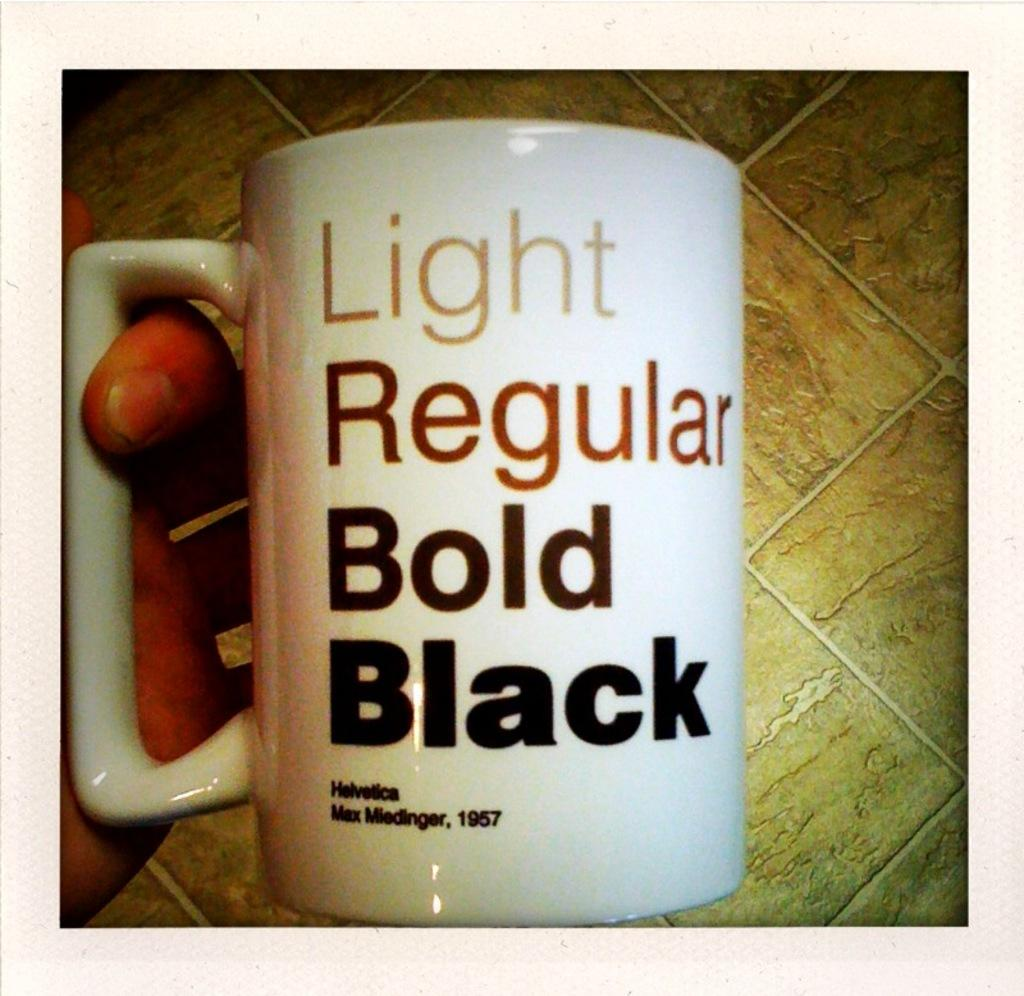<image>
Create a compact narrative representing the image presented. a mug with the text "light, regular, bold, black" in varying shades of brown 